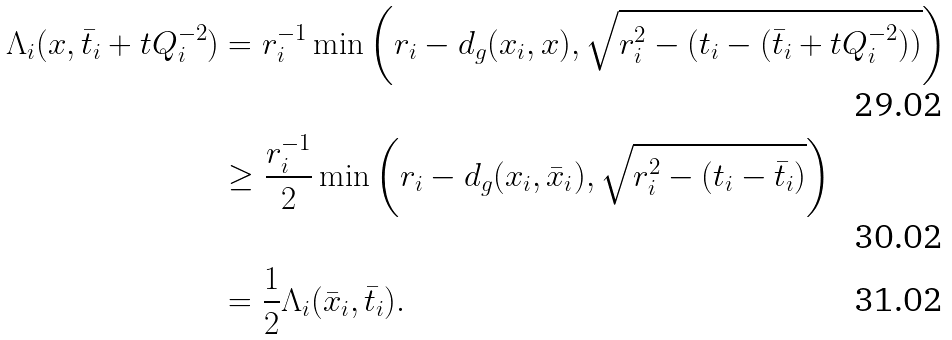<formula> <loc_0><loc_0><loc_500><loc_500>\Lambda _ { i } ( x , \bar { t } _ { i } + t Q _ { i } ^ { - 2 } ) & = r _ { i } ^ { - 1 } \min \left ( r _ { i } - d _ { g } ( x _ { i } , x ) , \sqrt { r _ { i } ^ { 2 } - ( t _ { i } - ( \bar { t } _ { i } + t Q _ { i } ^ { - 2 } ) ) } \right ) \\ & \geq \frac { r _ { i } ^ { - 1 } } { 2 } \min \left ( r _ { i } - d _ { g } ( x _ { i } , \bar { x } _ { i } ) , \sqrt { r _ { i } ^ { 2 } - ( t _ { i } - \bar { t } _ { i } ) } \right ) \\ & = \frac { 1 } { 2 } \Lambda _ { i } ( \bar { x } _ { i } , \bar { t } _ { i } ) .</formula> 